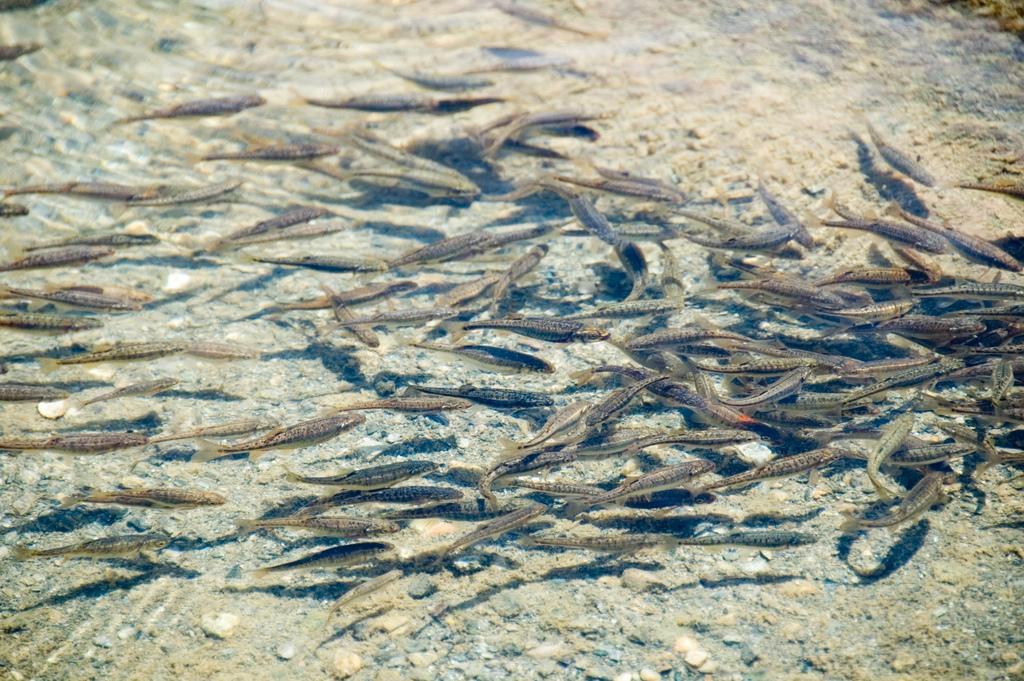Could you give a brief overview of what you see in this image? In this image there are fishes in water. 